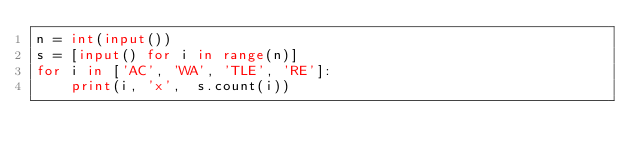<code> <loc_0><loc_0><loc_500><loc_500><_Python_>n = int(input())
s = [input() for i in range(n)]
for i in ['AC', 'WA', 'TLE', 'RE']:
    print(i, 'x',  s.count(i))</code> 